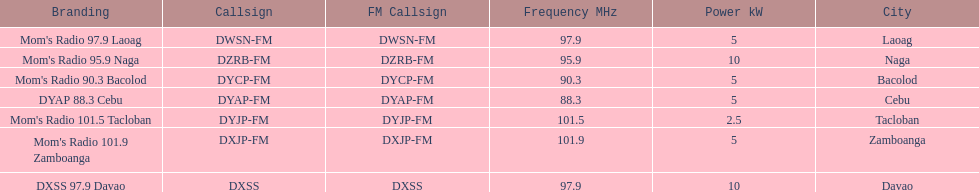What is the radio with the least about of mhz? DYAP 88.3 Cebu. 